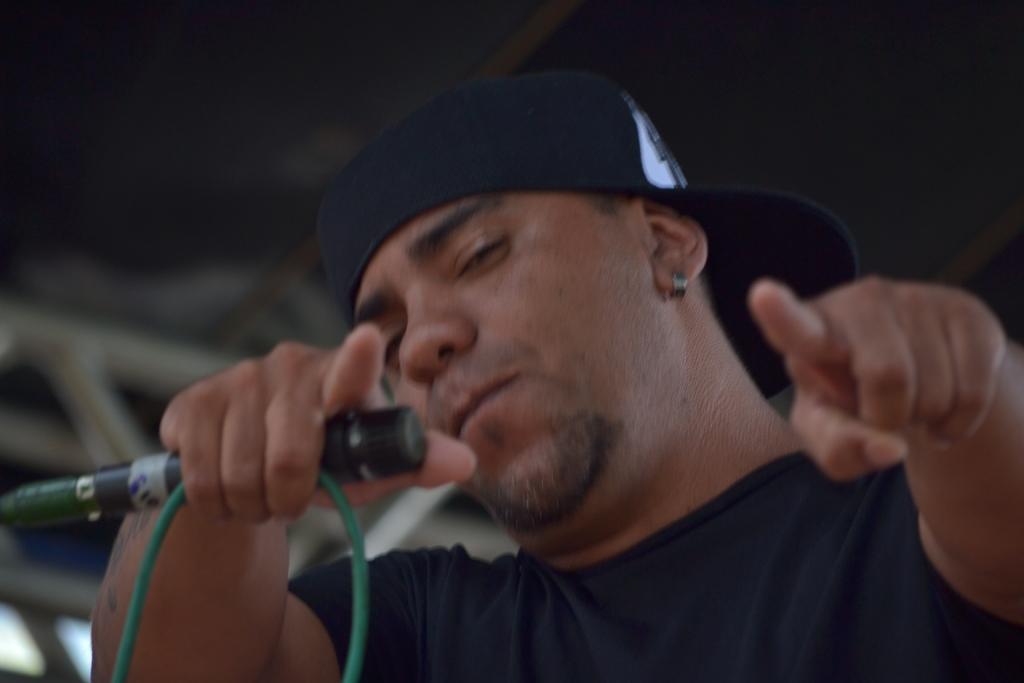Please provide a concise description of this image. This man wore black t-shirt, cap and holding mic. 